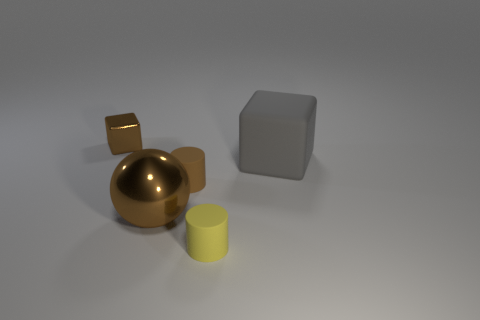Add 5 large brown things. How many objects exist? 10 Subtract 1 gray cubes. How many objects are left? 4 Subtract all balls. How many objects are left? 4 Subtract all cylinders. Subtract all metallic blocks. How many objects are left? 2 Add 5 yellow cylinders. How many yellow cylinders are left? 6 Add 4 large blue shiny cubes. How many large blue shiny cubes exist? 4 